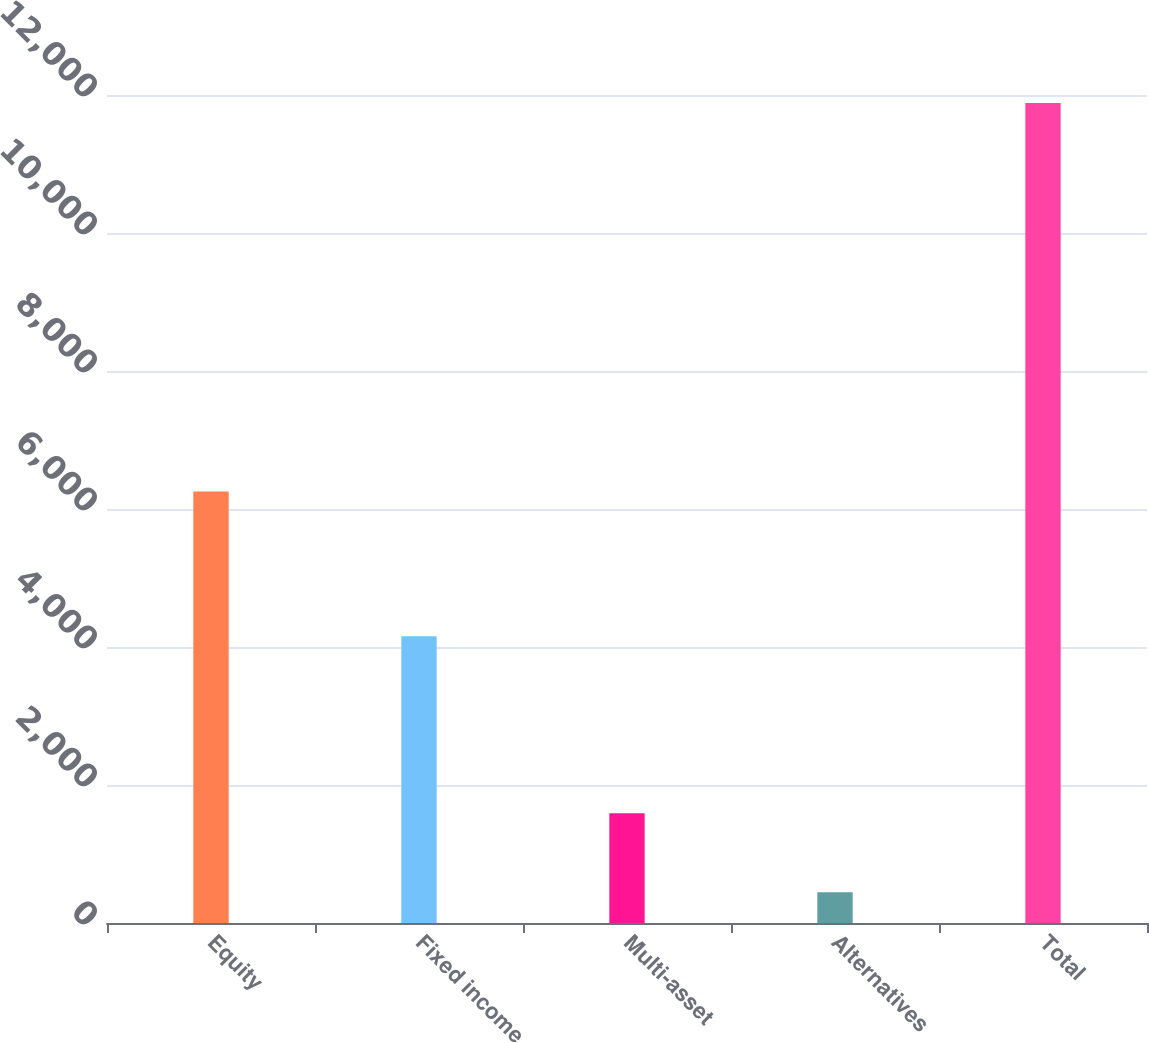Convert chart to OTSL. <chart><loc_0><loc_0><loc_500><loc_500><bar_chart><fcel>Equity<fcel>Fixed income<fcel>Multi-asset<fcel>Alternatives<fcel>Total<nl><fcel>6254<fcel>4157<fcel>1589.9<fcel>446<fcel>11885<nl></chart> 